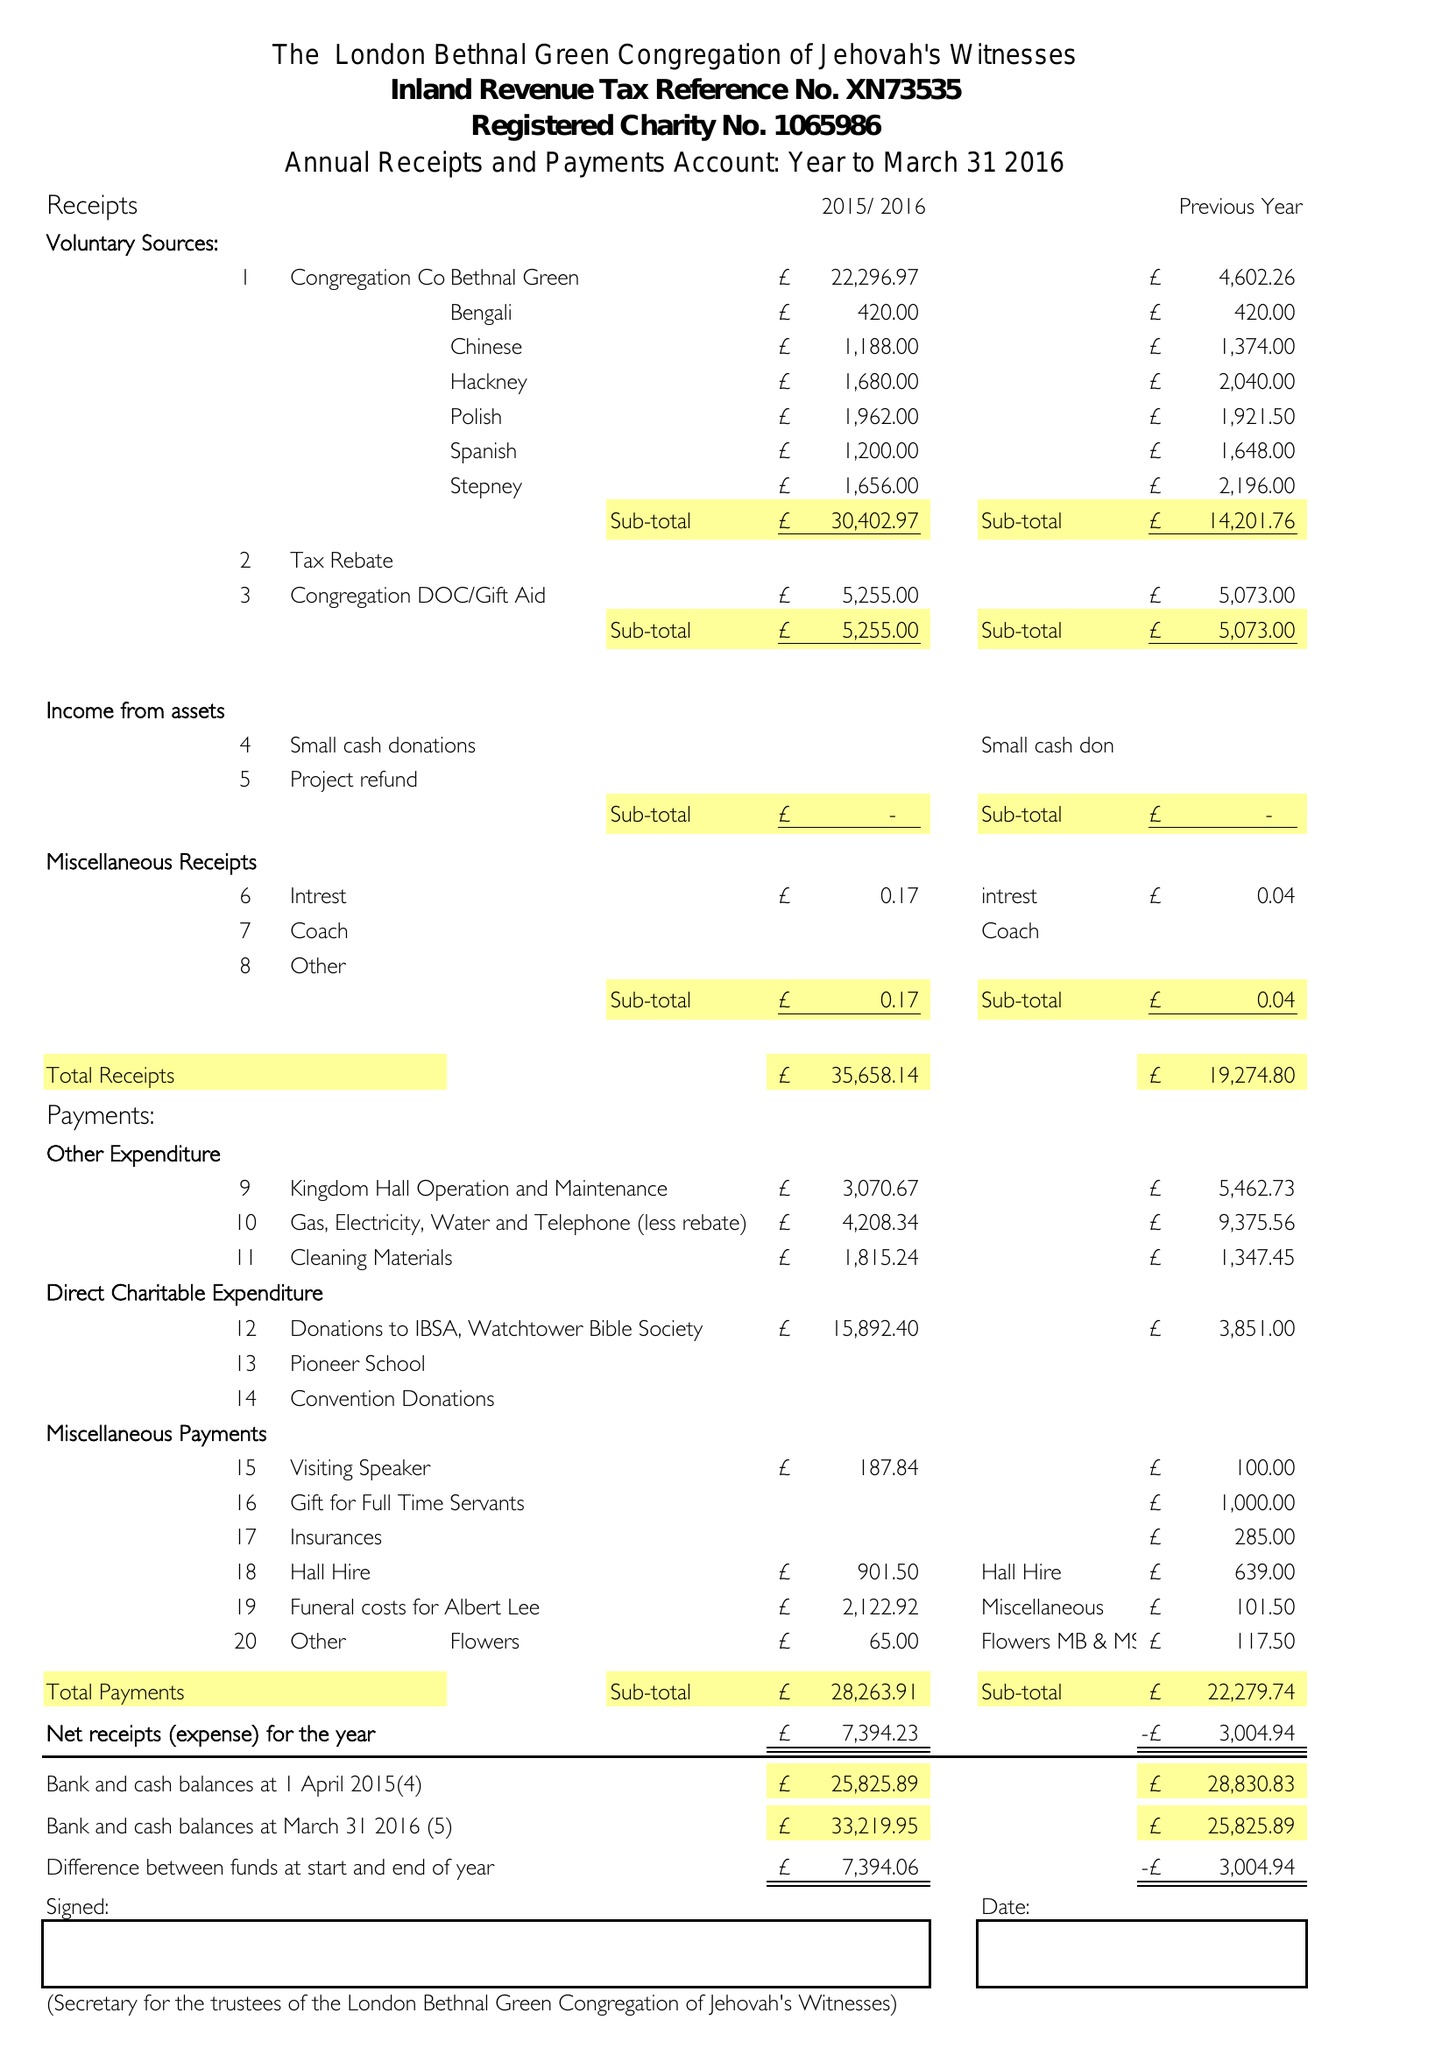What is the value for the spending_annually_in_british_pounds?
Answer the question using a single word or phrase. 28264.00 